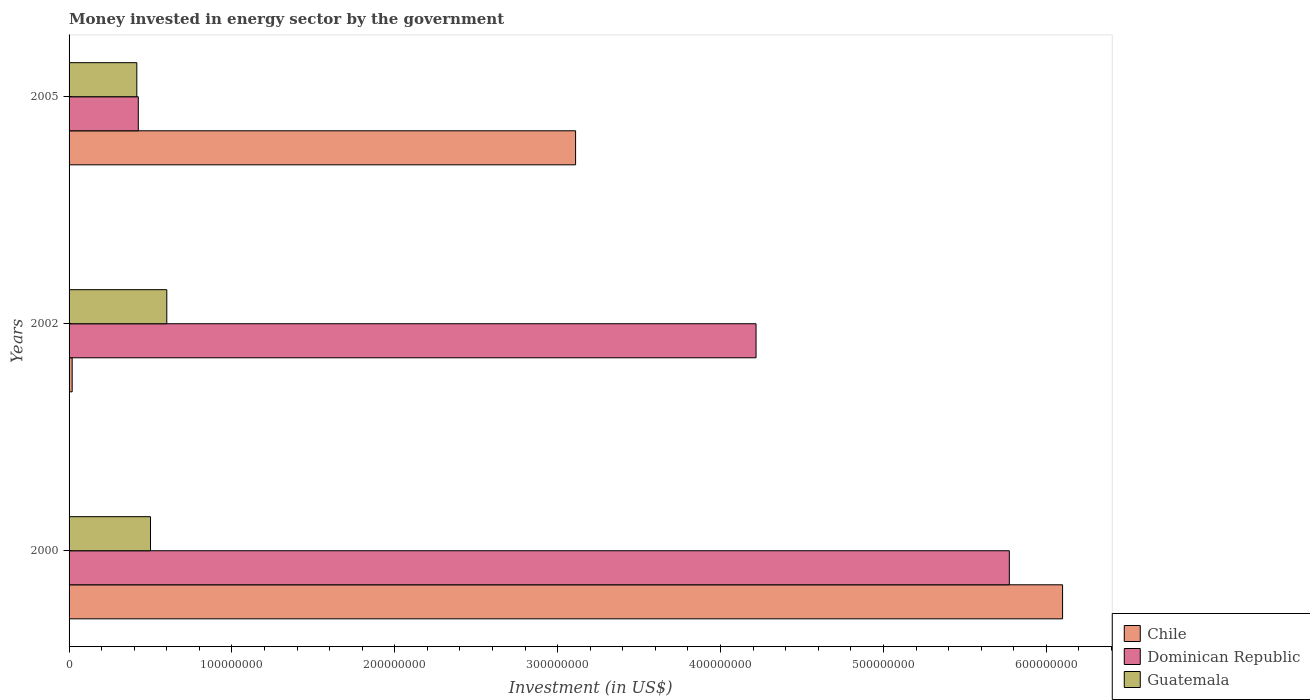How many different coloured bars are there?
Your answer should be very brief. 3. How many bars are there on the 3rd tick from the top?
Your answer should be compact. 3. How many bars are there on the 1st tick from the bottom?
Ensure brevity in your answer.  3. What is the money spent in energy sector in Dominican Republic in 2005?
Ensure brevity in your answer.  4.25e+07. Across all years, what is the maximum money spent in energy sector in Chile?
Your answer should be compact. 6.10e+08. Across all years, what is the minimum money spent in energy sector in Dominican Republic?
Provide a short and direct response. 4.25e+07. What is the total money spent in energy sector in Guatemala in the graph?
Offer a terse response. 1.52e+08. What is the difference between the money spent in energy sector in Guatemala in 2002 and that in 2005?
Provide a short and direct response. 1.84e+07. What is the difference between the money spent in energy sector in Dominican Republic in 2000 and the money spent in energy sector in Guatemala in 2002?
Provide a short and direct response. 5.17e+08. What is the average money spent in energy sector in Chile per year?
Ensure brevity in your answer.  3.08e+08. In the year 2002, what is the difference between the money spent in energy sector in Chile and money spent in energy sector in Dominican Republic?
Offer a very short reply. -4.20e+08. What is the ratio of the money spent in energy sector in Chile in 2002 to that in 2005?
Keep it short and to the point. 0.01. Is the difference between the money spent in energy sector in Chile in 2000 and 2002 greater than the difference between the money spent in energy sector in Dominican Republic in 2000 and 2002?
Ensure brevity in your answer.  Yes. What is the difference between the highest and the second highest money spent in energy sector in Dominican Republic?
Your response must be concise. 1.56e+08. What is the difference between the highest and the lowest money spent in energy sector in Dominican Republic?
Keep it short and to the point. 5.35e+08. What does the 3rd bar from the top in 2002 represents?
Your answer should be very brief. Chile. What does the 1st bar from the bottom in 2005 represents?
Offer a very short reply. Chile. Is it the case that in every year, the sum of the money spent in energy sector in Dominican Republic and money spent in energy sector in Guatemala is greater than the money spent in energy sector in Chile?
Provide a succinct answer. No. How many bars are there?
Make the answer very short. 9. Are all the bars in the graph horizontal?
Your response must be concise. Yes. Does the graph contain any zero values?
Ensure brevity in your answer.  No. Does the graph contain grids?
Offer a terse response. No. How many legend labels are there?
Offer a terse response. 3. What is the title of the graph?
Offer a terse response. Money invested in energy sector by the government. Does "Bhutan" appear as one of the legend labels in the graph?
Ensure brevity in your answer.  No. What is the label or title of the X-axis?
Make the answer very short. Investment (in US$). What is the Investment (in US$) in Chile in 2000?
Your answer should be very brief. 6.10e+08. What is the Investment (in US$) of Dominican Republic in 2000?
Provide a succinct answer. 5.77e+08. What is the Investment (in US$) of Chile in 2002?
Provide a short and direct response. 1.90e+06. What is the Investment (in US$) in Dominican Republic in 2002?
Your answer should be very brief. 4.22e+08. What is the Investment (in US$) in Guatemala in 2002?
Provide a short and direct response. 6.00e+07. What is the Investment (in US$) in Chile in 2005?
Your response must be concise. 3.11e+08. What is the Investment (in US$) in Dominican Republic in 2005?
Offer a very short reply. 4.25e+07. What is the Investment (in US$) of Guatemala in 2005?
Offer a very short reply. 4.16e+07. Across all years, what is the maximum Investment (in US$) in Chile?
Offer a terse response. 6.10e+08. Across all years, what is the maximum Investment (in US$) in Dominican Republic?
Your response must be concise. 5.77e+08. Across all years, what is the maximum Investment (in US$) of Guatemala?
Your response must be concise. 6.00e+07. Across all years, what is the minimum Investment (in US$) of Chile?
Your answer should be compact. 1.90e+06. Across all years, what is the minimum Investment (in US$) of Dominican Republic?
Your answer should be compact. 4.25e+07. Across all years, what is the minimum Investment (in US$) in Guatemala?
Your response must be concise. 4.16e+07. What is the total Investment (in US$) of Chile in the graph?
Provide a succinct answer. 9.23e+08. What is the total Investment (in US$) in Dominican Republic in the graph?
Your response must be concise. 1.04e+09. What is the total Investment (in US$) of Guatemala in the graph?
Offer a very short reply. 1.52e+08. What is the difference between the Investment (in US$) of Chile in 2000 and that in 2002?
Offer a terse response. 6.08e+08. What is the difference between the Investment (in US$) in Dominican Republic in 2000 and that in 2002?
Your answer should be compact. 1.56e+08. What is the difference between the Investment (in US$) in Guatemala in 2000 and that in 2002?
Provide a succinct answer. -1.00e+07. What is the difference between the Investment (in US$) in Chile in 2000 and that in 2005?
Your response must be concise. 2.99e+08. What is the difference between the Investment (in US$) of Dominican Republic in 2000 and that in 2005?
Give a very brief answer. 5.35e+08. What is the difference between the Investment (in US$) in Guatemala in 2000 and that in 2005?
Provide a short and direct response. 8.40e+06. What is the difference between the Investment (in US$) of Chile in 2002 and that in 2005?
Your answer should be compact. -3.09e+08. What is the difference between the Investment (in US$) in Dominican Republic in 2002 and that in 2005?
Your response must be concise. 3.79e+08. What is the difference between the Investment (in US$) in Guatemala in 2002 and that in 2005?
Offer a very short reply. 1.84e+07. What is the difference between the Investment (in US$) of Chile in 2000 and the Investment (in US$) of Dominican Republic in 2002?
Make the answer very short. 1.88e+08. What is the difference between the Investment (in US$) in Chile in 2000 and the Investment (in US$) in Guatemala in 2002?
Make the answer very short. 5.50e+08. What is the difference between the Investment (in US$) of Dominican Republic in 2000 and the Investment (in US$) of Guatemala in 2002?
Ensure brevity in your answer.  5.17e+08. What is the difference between the Investment (in US$) in Chile in 2000 and the Investment (in US$) in Dominican Republic in 2005?
Give a very brief answer. 5.68e+08. What is the difference between the Investment (in US$) in Chile in 2000 and the Investment (in US$) in Guatemala in 2005?
Your answer should be very brief. 5.68e+08. What is the difference between the Investment (in US$) of Dominican Republic in 2000 and the Investment (in US$) of Guatemala in 2005?
Give a very brief answer. 5.36e+08. What is the difference between the Investment (in US$) of Chile in 2002 and the Investment (in US$) of Dominican Republic in 2005?
Offer a terse response. -4.06e+07. What is the difference between the Investment (in US$) in Chile in 2002 and the Investment (in US$) in Guatemala in 2005?
Give a very brief answer. -3.97e+07. What is the difference between the Investment (in US$) in Dominican Republic in 2002 and the Investment (in US$) in Guatemala in 2005?
Provide a succinct answer. 3.80e+08. What is the average Investment (in US$) of Chile per year?
Keep it short and to the point. 3.08e+08. What is the average Investment (in US$) in Dominican Republic per year?
Make the answer very short. 3.47e+08. What is the average Investment (in US$) of Guatemala per year?
Offer a terse response. 5.05e+07. In the year 2000, what is the difference between the Investment (in US$) of Chile and Investment (in US$) of Dominican Republic?
Offer a terse response. 3.27e+07. In the year 2000, what is the difference between the Investment (in US$) of Chile and Investment (in US$) of Guatemala?
Give a very brief answer. 5.60e+08. In the year 2000, what is the difference between the Investment (in US$) of Dominican Republic and Investment (in US$) of Guatemala?
Keep it short and to the point. 5.27e+08. In the year 2002, what is the difference between the Investment (in US$) in Chile and Investment (in US$) in Dominican Republic?
Ensure brevity in your answer.  -4.20e+08. In the year 2002, what is the difference between the Investment (in US$) in Chile and Investment (in US$) in Guatemala?
Provide a short and direct response. -5.81e+07. In the year 2002, what is the difference between the Investment (in US$) of Dominican Republic and Investment (in US$) of Guatemala?
Ensure brevity in your answer.  3.62e+08. In the year 2005, what is the difference between the Investment (in US$) of Chile and Investment (in US$) of Dominican Republic?
Provide a succinct answer. 2.68e+08. In the year 2005, what is the difference between the Investment (in US$) of Chile and Investment (in US$) of Guatemala?
Your answer should be very brief. 2.69e+08. In the year 2005, what is the difference between the Investment (in US$) of Dominican Republic and Investment (in US$) of Guatemala?
Your answer should be very brief. 9.00e+05. What is the ratio of the Investment (in US$) in Chile in 2000 to that in 2002?
Offer a terse response. 321.05. What is the ratio of the Investment (in US$) in Dominican Republic in 2000 to that in 2002?
Make the answer very short. 1.37. What is the ratio of the Investment (in US$) in Guatemala in 2000 to that in 2002?
Your answer should be very brief. 0.83. What is the ratio of the Investment (in US$) of Chile in 2000 to that in 2005?
Provide a short and direct response. 1.96. What is the ratio of the Investment (in US$) in Dominican Republic in 2000 to that in 2005?
Your answer should be very brief. 13.58. What is the ratio of the Investment (in US$) of Guatemala in 2000 to that in 2005?
Give a very brief answer. 1.2. What is the ratio of the Investment (in US$) of Chile in 2002 to that in 2005?
Your answer should be very brief. 0.01. What is the ratio of the Investment (in US$) in Dominican Republic in 2002 to that in 2005?
Offer a terse response. 9.92. What is the ratio of the Investment (in US$) in Guatemala in 2002 to that in 2005?
Your response must be concise. 1.44. What is the difference between the highest and the second highest Investment (in US$) of Chile?
Provide a short and direct response. 2.99e+08. What is the difference between the highest and the second highest Investment (in US$) of Dominican Republic?
Provide a succinct answer. 1.56e+08. What is the difference between the highest and the second highest Investment (in US$) in Guatemala?
Make the answer very short. 1.00e+07. What is the difference between the highest and the lowest Investment (in US$) in Chile?
Offer a terse response. 6.08e+08. What is the difference between the highest and the lowest Investment (in US$) of Dominican Republic?
Your response must be concise. 5.35e+08. What is the difference between the highest and the lowest Investment (in US$) of Guatemala?
Your answer should be compact. 1.84e+07. 